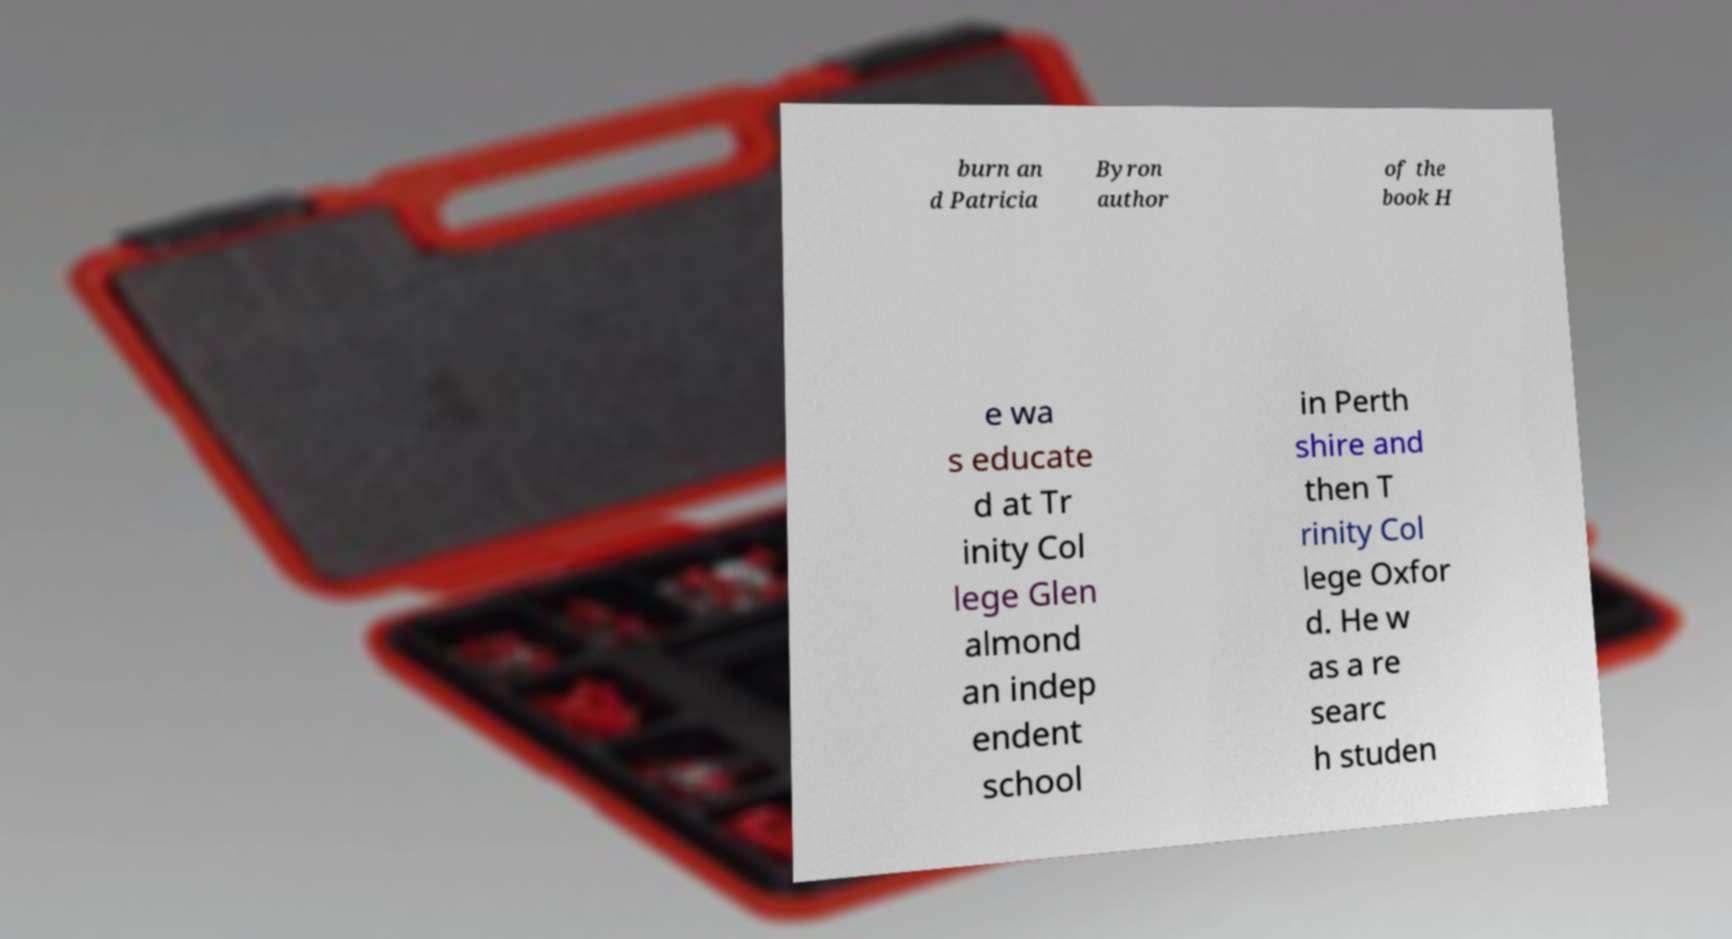There's text embedded in this image that I need extracted. Can you transcribe it verbatim? burn an d Patricia Byron author of the book H e wa s educate d at Tr inity Col lege Glen almond an indep endent school in Perth shire and then T rinity Col lege Oxfor d. He w as a re searc h studen 